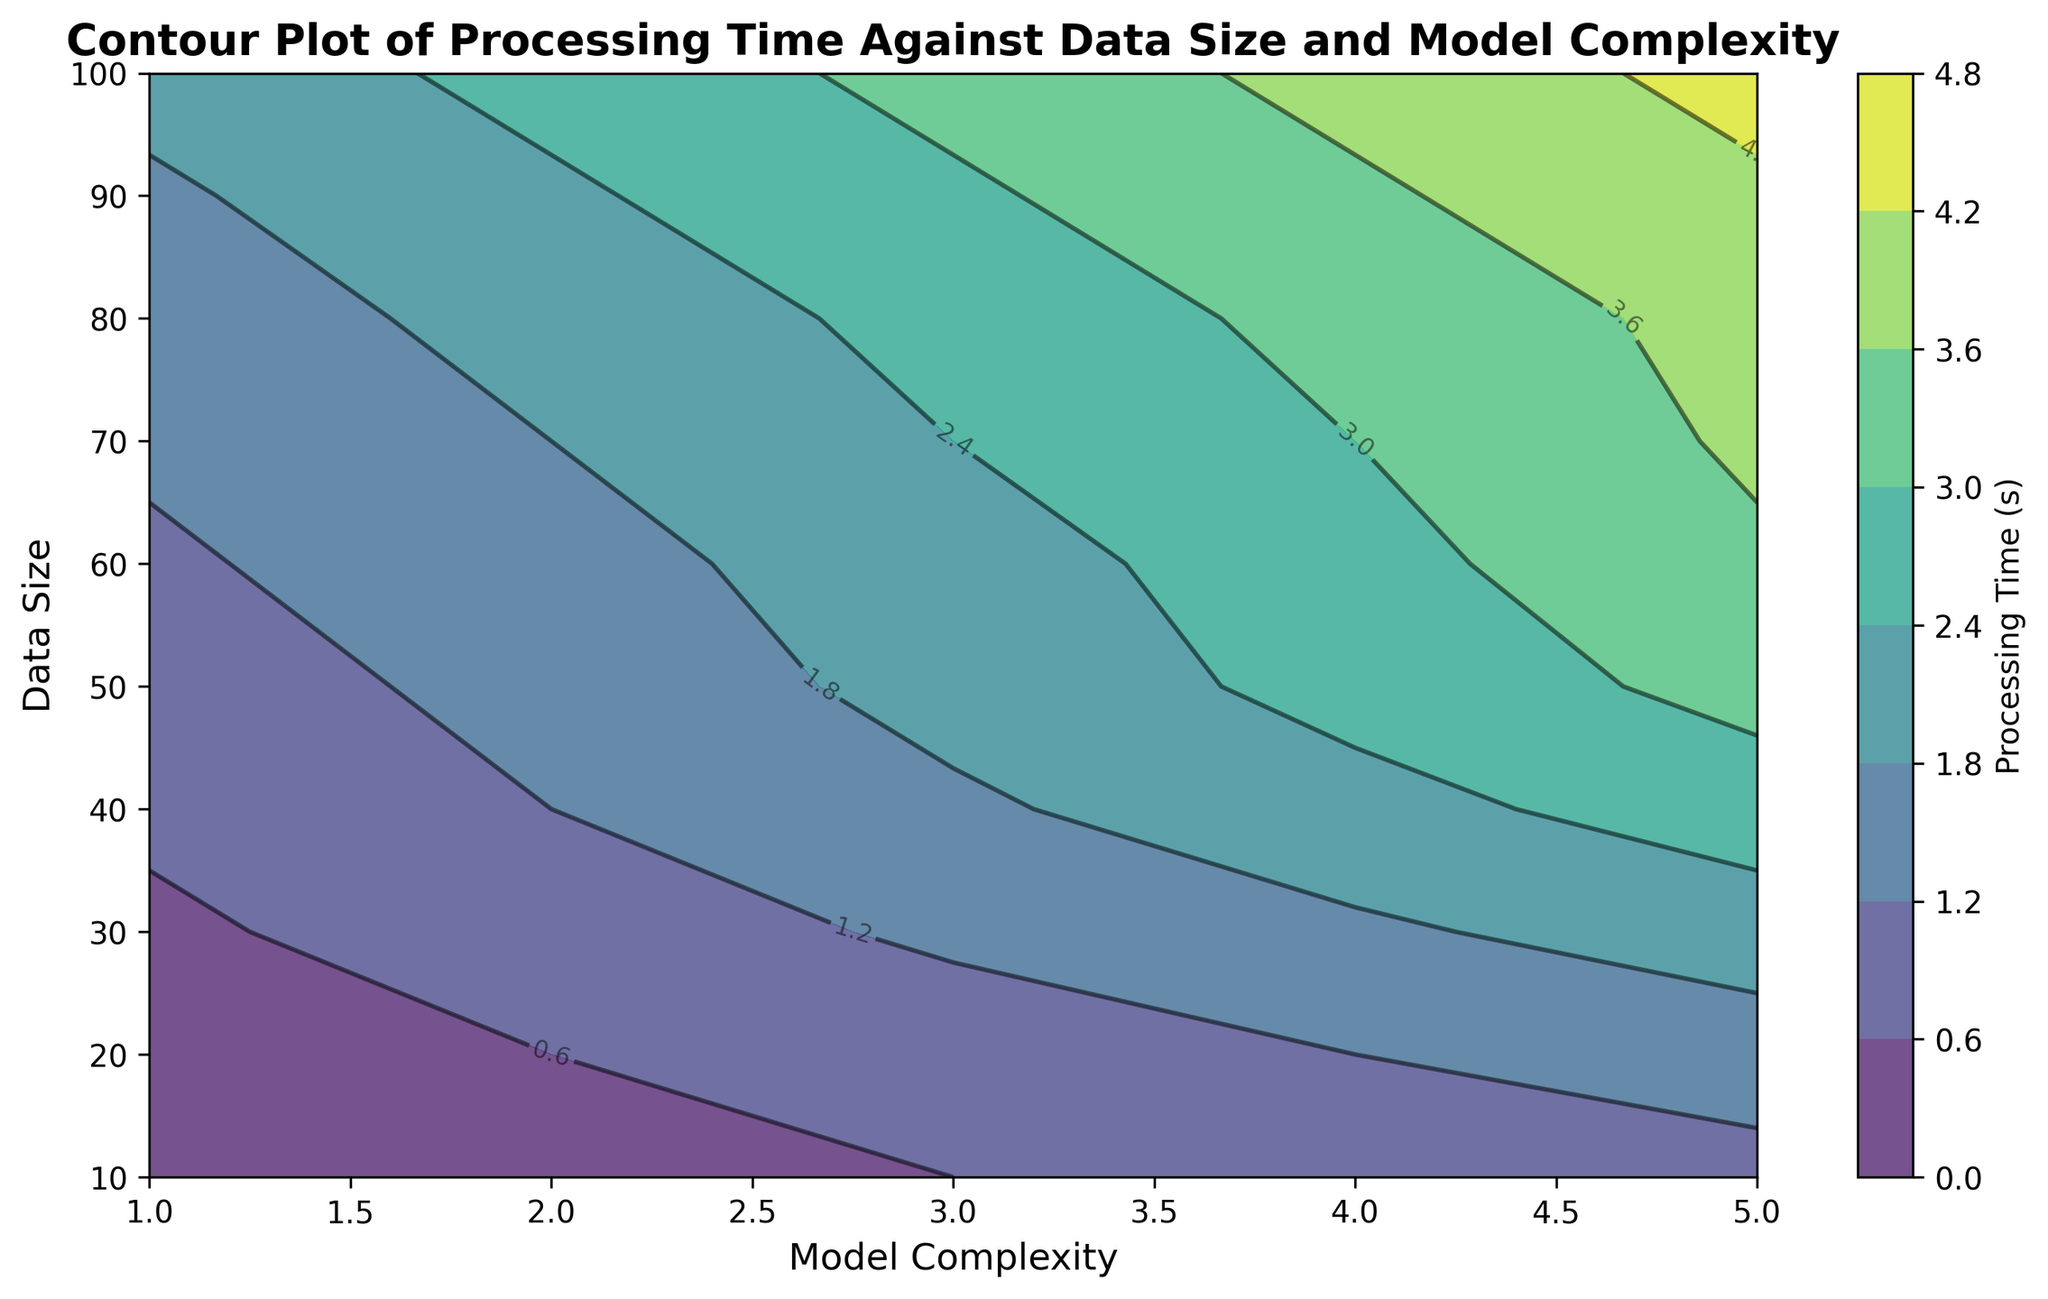What is the processing time for the smallest data size with the highest model complexity? To find this, look at the point where Data Size is at its minimum value (10) and Model Complexity is at its maximum value (5). According to the contour plot, the processing time here is indicated.
Answer: 1.0 What is the difference in processing time between the smallest and largest data sizes for the simplest model complexity? Locate the processing times for the smallest (10) and largest (100) data sizes at Model Complexity = 1. Subtract the processing time for the smallest data size from the processing time for the largest data size. According to the contour plot, these values are 0.2 and 2.0, respectively. So, the difference is 2.0 - 0.2.
Answer: 1.8 Which combination of data size and model complexity results in the highest processing time? Identify the darkest area on the contour plot, indicating the highest processing time. From the plot, this area corresponds to Data Size = 100 and Model Complexity = 5.
Answer: Data Size = 100, Model Complexity = 5 Is there a linear relationship between data size and processing time for a fixed model complexity? Observe the contour lines along a specific Model Complexity value. The contour lines appear to form a consistent slope, indicating a linear relationship between Data Size and Processing Time for a fixed Model Complexity.
Answer: Yes What is the average processing time for a data size of 50 across all model complexities? Check the processing times for Data Size = 50 across all Model Complexity values (1 to 5). These values are 0.9, 1.4, 2.0, 2.6, and 3.2. Calculate the average: (0.9 + 1.4 + 2.0 + 2.6 + 3.2) / 5.
Answer: 2.02 Compare the processing times for model complexities of 2 and 4 for a data size of 80. Which one is higher? Find the points where Data Size = 80 intersects with Model Complexity = 2 and Model Complexity = 4 on the contour plot. The processing times are 2.0 and 3.2, respectively. Comparing these values indicates that the processing time for Model Complexity 4 is higher.
Answer: Model Complexity 4 How does the processing time change when increasing the model complexity from 1 to 5 for a data size of 30? Examine the contour lines along Data Size = 30. Observe the progression from Model Complexity = 1 to Model Complexity = 5. The processing times increase from 0.5 to 2.1.
Answer: Increases For which data size does the processing time first exceed 3 seconds for model complexity 3? Follow the contour line for Model Complexity = 3 until the processing time exceeds 3 seconds. This happens at a Data Size of around 80.
Answer: 80 Which data size and model complexity combination has the least change in processing time between the contour levels? Identify the flattest region within the contour plot indicating minimal changes in processing time. This region is Data Size around 20 and Model Complexity around 1 to 2.
Answer: Data Size = 20, Model Complexity = 1-2 